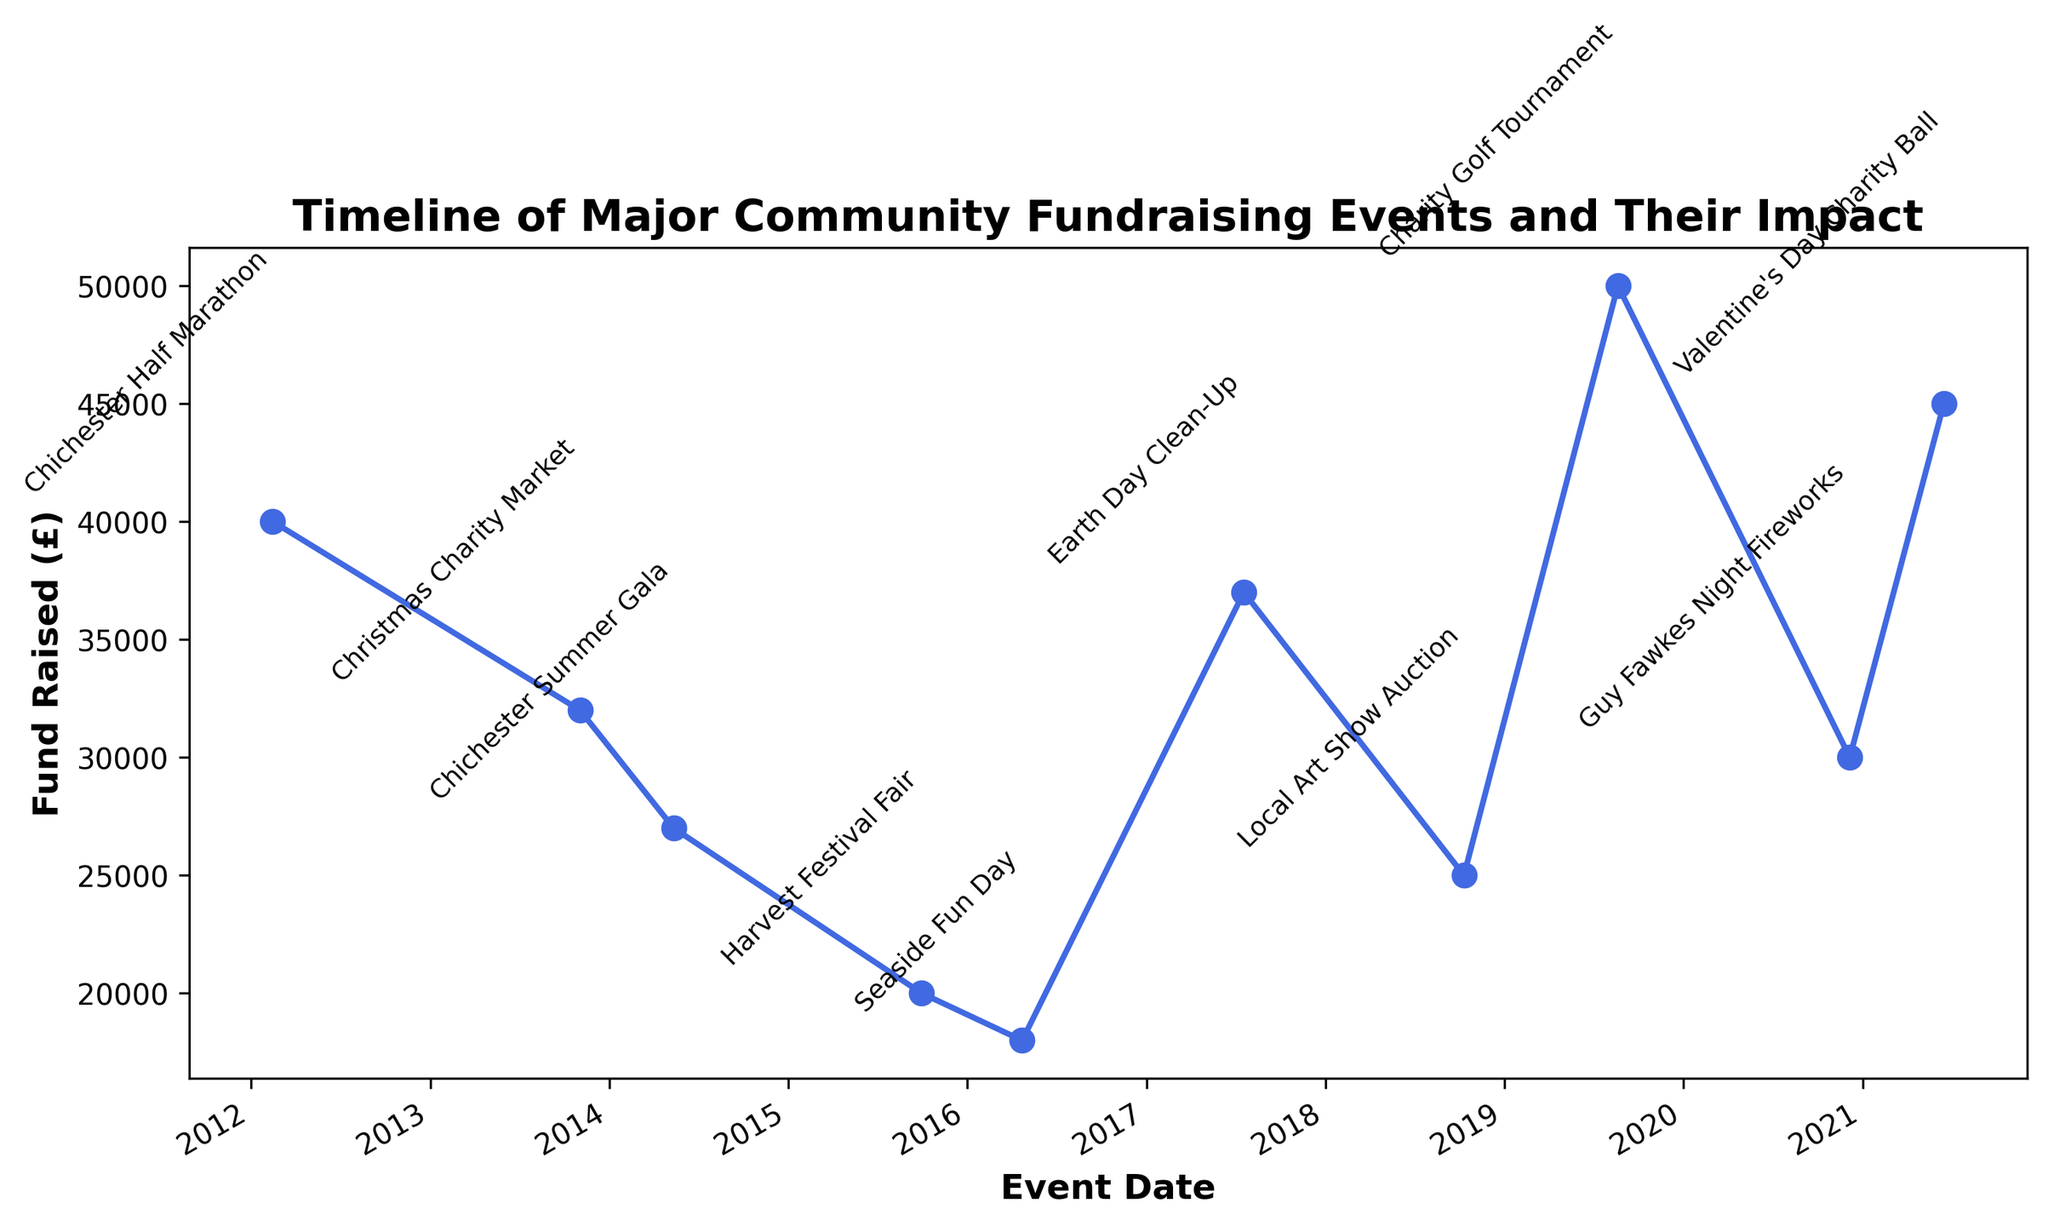What was the total amount raised by all the events combined? First, identify all the amounts raised: £45000, £30000, £50000, £25000, £37000, £18000, £20000, £27000, £32000, and £40000. Add them together: £45000 + £30000 + £50000 + £25000 + £37000 + £18000 + £20000 + £27000 + £32000 + £40000 = £324000
Answer: £324000 Which event raised the highest amount of funds? Look at the y-values on the graph and identify the highest point. The highest point is £50000, which corresponds to the Chichester Summer Gala
Answer: Chichester Summer Gala How much more did the Chichester Half Marathon raise compared to the Seaside Fun Day? Find the y-values for each event. The Chichester Half Marathon raised £45000 and the Seaside Fun Day raised £37000. Subtract the latter from the former: £45000 - £37000 = £8000
Answer: £8000 What is the difference in funds raised between the event with the lowest funds and the event with the highest funds? Identify the lowest and highest y-values on the graph. The lowest is £18000 (Earth Day Clean-Up) and the highest is £50000 (Chichester Summer Gala). Subtract the lowest from the highest: £50000 - £18000 = £32000
Answer: £32000 Which event took place earliest on the timeline? The earliest date on the x-axis is February 14, 2012, which matches the Valentine's Day Charity Ball
Answer: Valentine's Day Charity Ball What is the average amount of funds raised per event? Sum all the funds raised and divide by the number of events. The total funds raised is £324000, and there are 10 events. The average is £324000 / 10 = £32400
Answer: £32400 How many events raised more than £30000? Identify the y-values that are greater than £30000: £45000 (Chichester Half Marathon), £30000 (Christmas Charity Market), £50000 (Chichester Summer Gala), £37000 (Seaside Fun Day), £32000 (Guy Fawkes Night Fireworks), and £40000 (Valentine's Day Charity Ball). There are 6 events in total
Answer: 6 Which event had the smallest impact in terms of funds raised? Identify the lowest y-value on the graph, which corresponds to £18000 raised by Earth Day Clean-Up
Answer: Earth Day Clean-Up What is the median amount of funds raised across all events? List all amounts in ascending order: £18000, £20000, £25000, £27000, £30000, £32000, £37000, £40000, £45000, £50000. The median (middle) value is the average of the 5th and 6th values: (£30000 + £32000) / 2 = £31000
Answer: £31000 